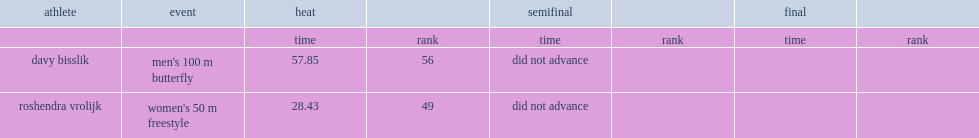What was the result that davy bisslik got in the heat? 57.85. 